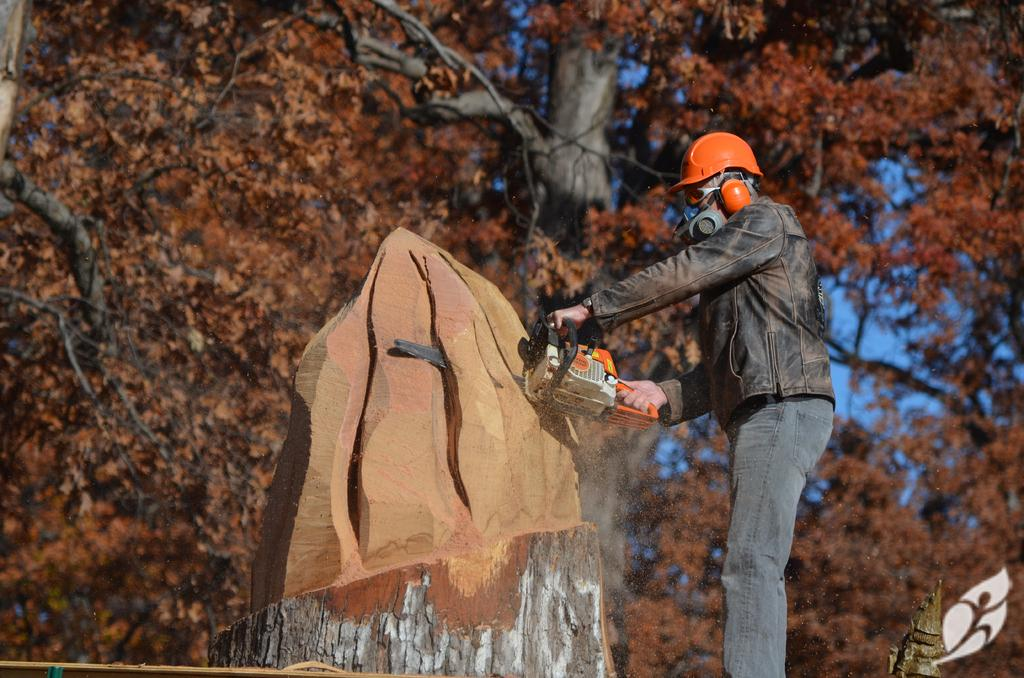What is the main subject of the image? There is a person standing in the image. What is the person holding in the image? The person is holding an object. What can be seen in the background of the image? There are trees in the background of the image. What color is the sky in the image? The sky is blue in the image. What else is visible in the image besides the person and trees? There is a trunk visible in the image. How many legs does the fish have in the image? There is no fish present in the image, so it is not possible to determine the number of legs it might have. 